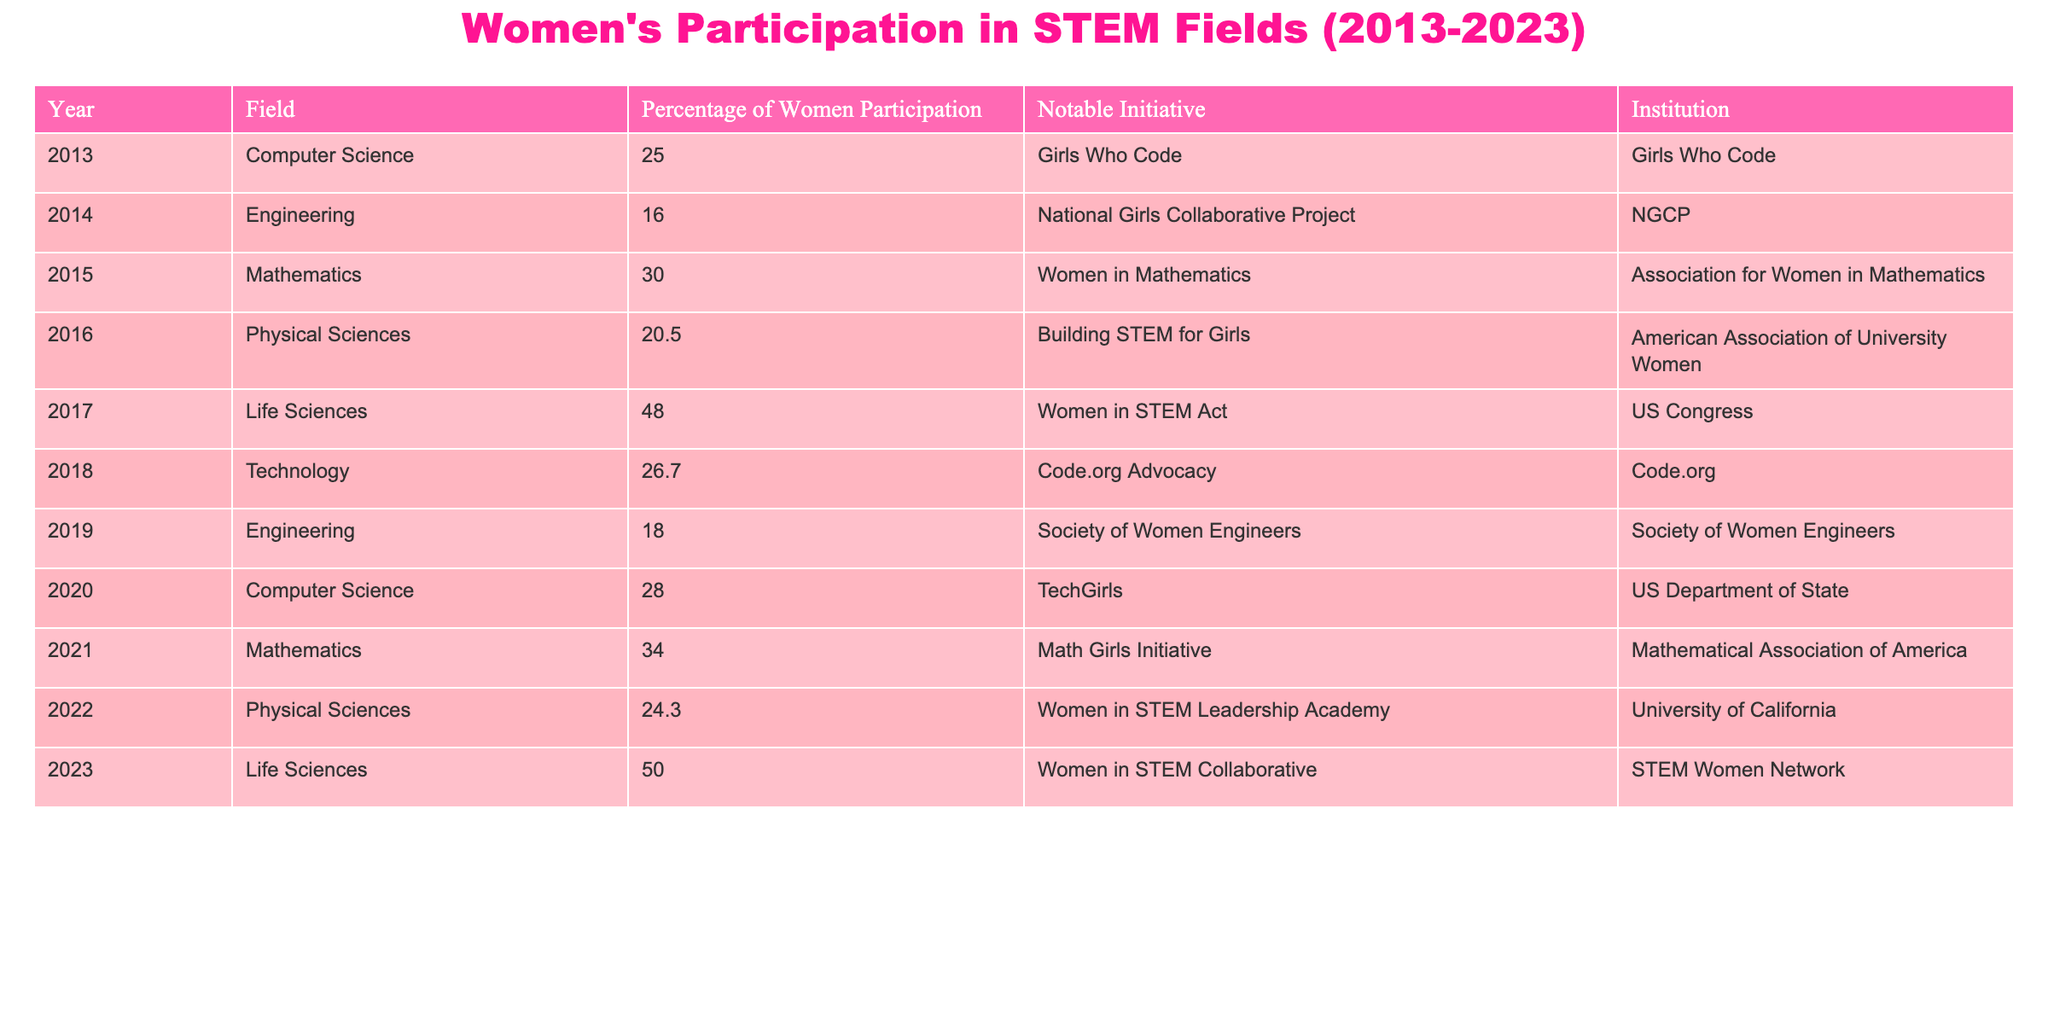What was the percentage of women participating in Computer Science in 2013? According to the table, in the year 2013, the percentage of women participating in Computer Science was specifically stated as 25.0%
Answer: 25.0% Which field had the highest percentage of female participation in 2023? The table indicates that in 2023, Life Sciences had the highest percentage of female participation at 50.0%
Answer: 50.0% What is the percentage increase in women's participation in Life Sciences from 2017 to 2023? In 2017, the percentage was 48.0%, and in 2023, it increased to 50.0%. The increase is calculated as 50.0 - 48.0 = 2.0%, so the percentage increase is 2.0%
Answer: 2.0% Did the percentage of women in Engineering increase over the decade? Referring to the table, Engineering started at 16.0% in 2014 and fluctuated, reaching only 18.0% in 2019, then no data for the following years. Since it didn’t reach or exceed its starting percentage by the end of the decade, the answer is no
Answer: No What was the average percentage of women participating in Mathematics from 2015 to 2021? The percentages for Mathematics over those years are 30.0% (2015), 34.0% (2021). To find the average, sum them: 30.0 + 34.0 = 64.0, then divide by the number of years (2), resulting in an average of 32.0%
Answer: 32.0% Which notable initiative was associated with the highest women participation in 2023? The table shows that the notable initiative associated with Life Sciences, which had the highest participation percentage of 50.0% in 2023, is "Women in STEM Collaborative"
Answer: Women in STEM Collaborative How many total notable initiatives were mentioned in the table? The total notable initiatives listed in the table are 11. You can count each unique mention under the Notable Initiative column to verify this
Answer: 11 In which year did the percentage of women's participation in Technology peak in the given data? The table indicates that the highest percentage for Technology was 26.7% in 2018. This can be confirmed by reviewing the values listed for the Technology field across the years presented
Answer: 2018 By how much percentage did women's participation in Physical Sciences decrease from 2016 to 2022? In 2016, the participation was 20.5% and decreased to 24.3% in 2022. The decrease is calculated as 24.3 - 20.5 = -3.8%. Since it is a decrease, the value is noted as negative
Answer: 3.8% 